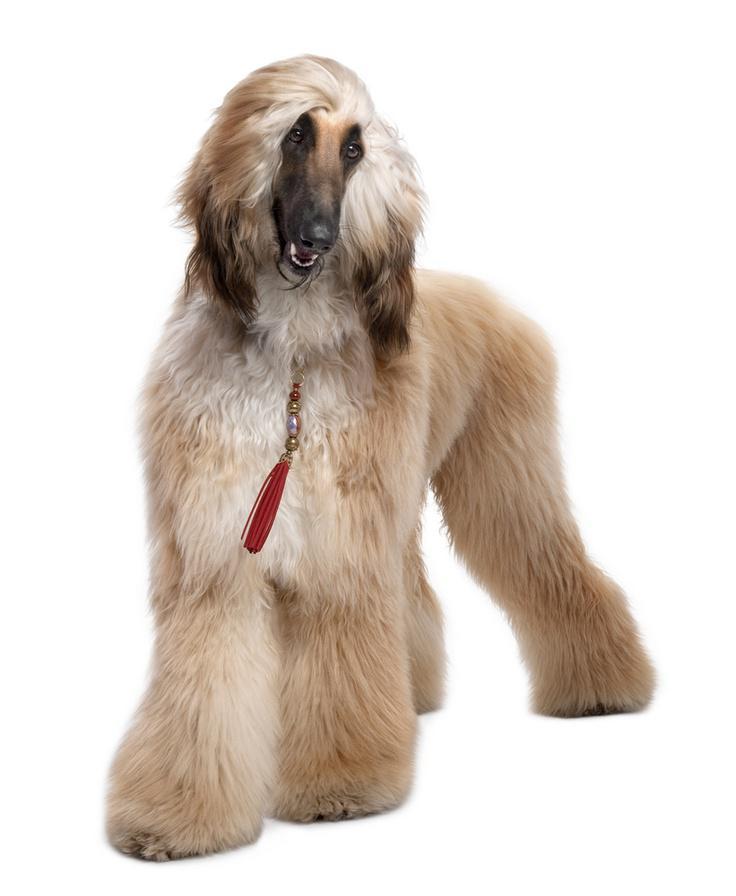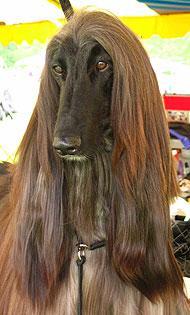The first image is the image on the left, the second image is the image on the right. Given the left and right images, does the statement "Both dogs' mouths are open." hold true? Answer yes or no. No. 